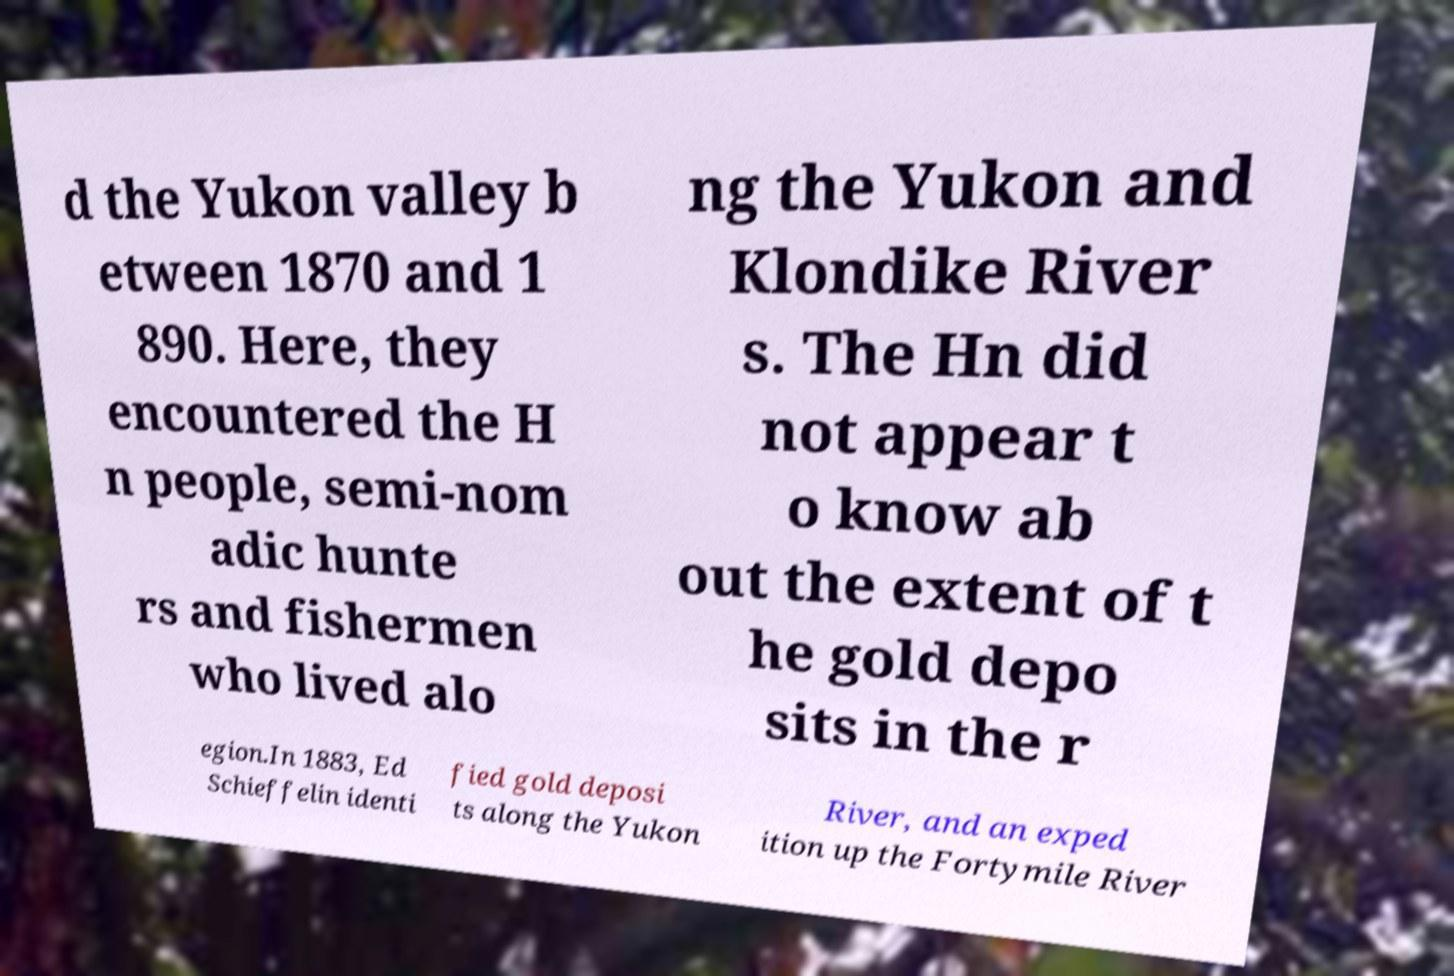Could you assist in decoding the text presented in this image and type it out clearly? d the Yukon valley b etween 1870 and 1 890. Here, they encountered the H n people, semi-nom adic hunte rs and fishermen who lived alo ng the Yukon and Klondike River s. The Hn did not appear t o know ab out the extent of t he gold depo sits in the r egion.In 1883, Ed Schieffelin identi fied gold deposi ts along the Yukon River, and an exped ition up the Fortymile River 